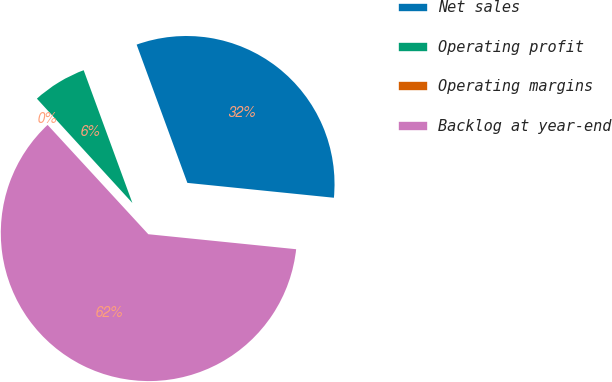<chart> <loc_0><loc_0><loc_500><loc_500><pie_chart><fcel>Net sales<fcel>Operating profit<fcel>Operating margins<fcel>Backlog at year-end<nl><fcel>32.21%<fcel>6.2%<fcel>0.05%<fcel>61.55%<nl></chart> 